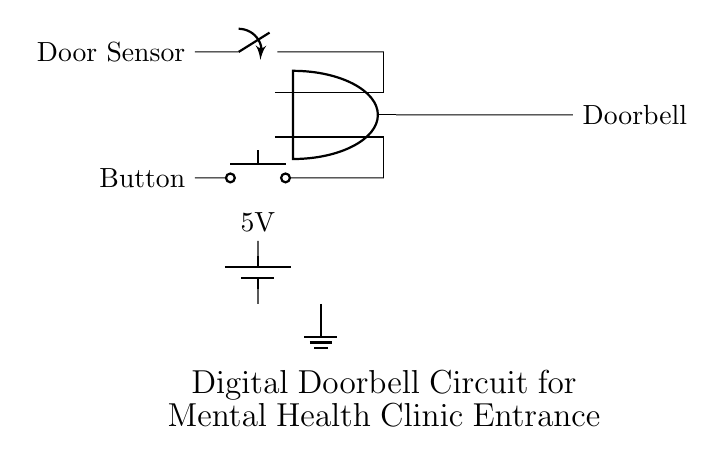What is the function of the AND gate in this circuit? The AND gate outputs a signal only when both of its inputs are active (high). In this circuit, the doorbell will ring only if both the Door Sensor and Button are activated.
Answer: Doorbell activation What supplies power to the circuit? The circuit is powered by a 5V battery. The battery connection is clearly indicated in the circuit diagram, providing necessary voltage for operation.
Answer: 5V battery How many inputs does the AND gate have? The AND gate shown in the circuit has two inputs, one connected to the Door Sensor and the other to the Button. This is a defining characteristic of this type of gate.
Answer: Two inputs What happens if only one input of the AND gate is high? If only one input is high, the AND gate will output low, meaning the doorbell will not ring. This demonstrates the gate's requirement for both inputs to be active for a positive output.
Answer: Doorbell does not ring What is the purpose of the push button in this circuit? The push button allows manual interaction to activate the circuit when pressed, acting as one of the inputs to the AND gate alongside the Door Sensor.
Answer: Manual activation Are there any components that can create a ground connection? Yes, the circuit features a ground connection as indicated by the ground symbol, which provides a reference point in the circuit and completes the electrical path.
Answer: Ground connection 